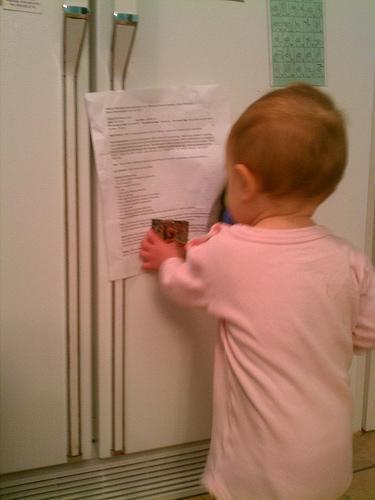How many handles are on the refrigerator?
Give a very brief answer. 2. How many people are in the picture?
Give a very brief answer. 1. 